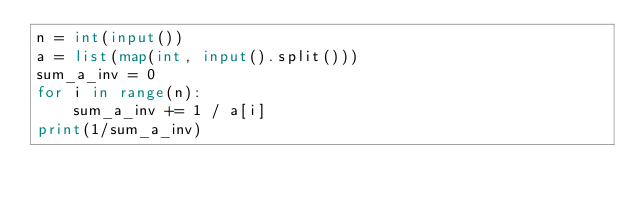Convert code to text. <code><loc_0><loc_0><loc_500><loc_500><_Python_>n = int(input())
a = list(map(int, input().split()))
sum_a_inv = 0
for i in range(n):
    sum_a_inv += 1 / a[i]
print(1/sum_a_inv)</code> 